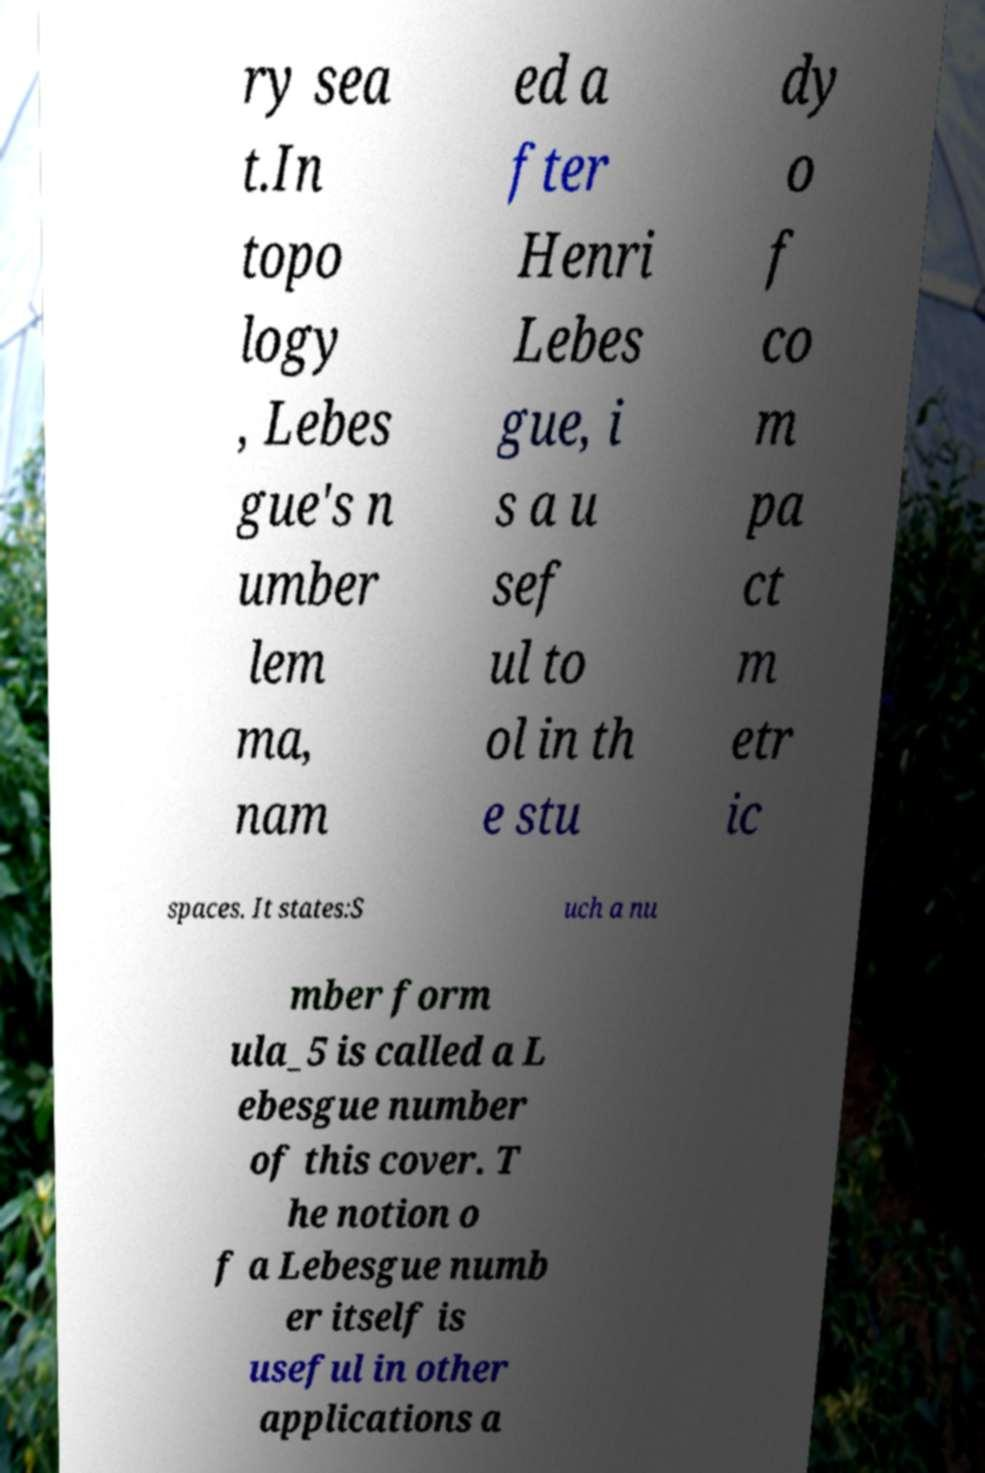What messages or text are displayed in this image? I need them in a readable, typed format. ry sea t.In topo logy , Lebes gue's n umber lem ma, nam ed a fter Henri Lebes gue, i s a u sef ul to ol in th e stu dy o f co m pa ct m etr ic spaces. It states:S uch a nu mber form ula_5 is called a L ebesgue number of this cover. T he notion o f a Lebesgue numb er itself is useful in other applications a 